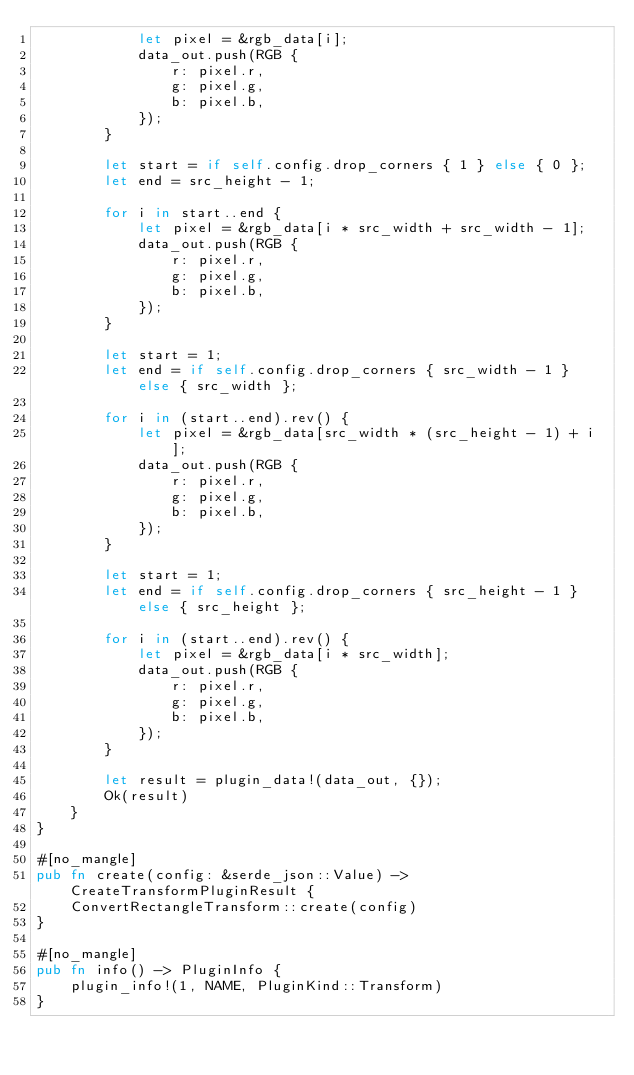Convert code to text. <code><loc_0><loc_0><loc_500><loc_500><_Rust_>            let pixel = &rgb_data[i];
            data_out.push(RGB {
                r: pixel.r,
                g: pixel.g,
                b: pixel.b,
            });
        }

        let start = if self.config.drop_corners { 1 } else { 0 };
        let end = src_height - 1;

        for i in start..end {
            let pixel = &rgb_data[i * src_width + src_width - 1];
            data_out.push(RGB {
                r: pixel.r,
                g: pixel.g,
                b: pixel.b,
            });
        }

        let start = 1;
        let end = if self.config.drop_corners { src_width - 1 } else { src_width };

        for i in (start..end).rev() {
            let pixel = &rgb_data[src_width * (src_height - 1) + i];
            data_out.push(RGB {
                r: pixel.r,
                g: pixel.g,
                b: pixel.b,
            });
        }

        let start = 1;
        let end = if self.config.drop_corners { src_height - 1 } else { src_height };

        for i in (start..end).rev() {
            let pixel = &rgb_data[i * src_width];
            data_out.push(RGB {
                r: pixel.r,
                g: pixel.g,
                b: pixel.b,
            });
        }

        let result = plugin_data!(data_out, {});
        Ok(result)
    }
}

#[no_mangle]
pub fn create(config: &serde_json::Value) -> CreateTransformPluginResult {
    ConvertRectangleTransform::create(config)
}

#[no_mangle]
pub fn info() -> PluginInfo {
    plugin_info!(1, NAME, PluginKind::Transform)
}
</code> 